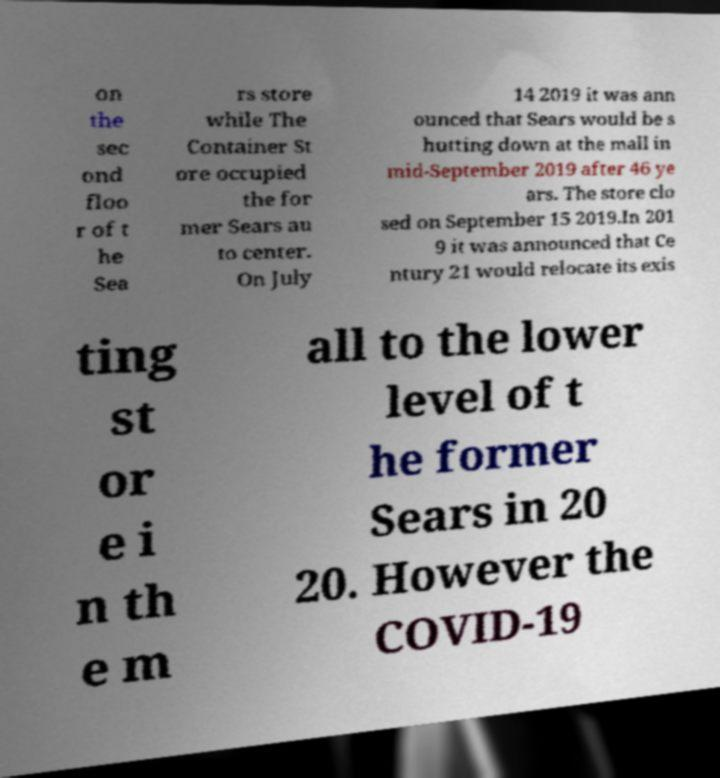Can you accurately transcribe the text from the provided image for me? on the sec ond floo r of t he Sea rs store while The Container St ore occupied the for mer Sears au to center. On July 14 2019 it was ann ounced that Sears would be s hutting down at the mall in mid-September 2019 after 46 ye ars. The store clo sed on September 15 2019.In 201 9 it was announced that Ce ntury 21 would relocate its exis ting st or e i n th e m all to the lower level of t he former Sears in 20 20. However the COVID-19 